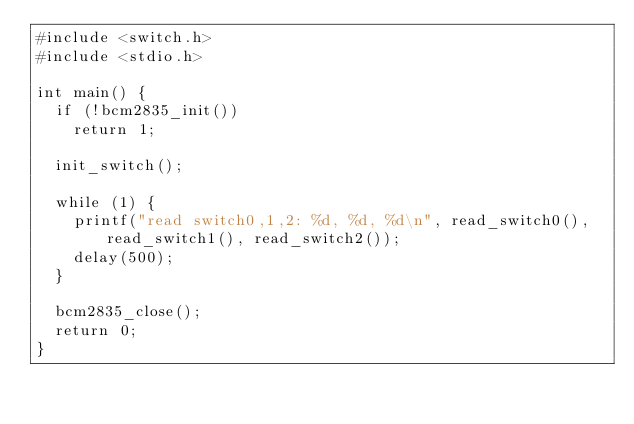Convert code to text. <code><loc_0><loc_0><loc_500><loc_500><_C++_>#include <switch.h>
#include <stdio.h>

int main() {
  if (!bcm2835_init())
    return 1;

  init_switch();

  while (1) {
    printf("read switch0,1,2: %d, %d, %d\n", read_switch0(), read_switch1(), read_switch2());
    delay(500);
  }

  bcm2835_close();
  return 0;
}
</code> 